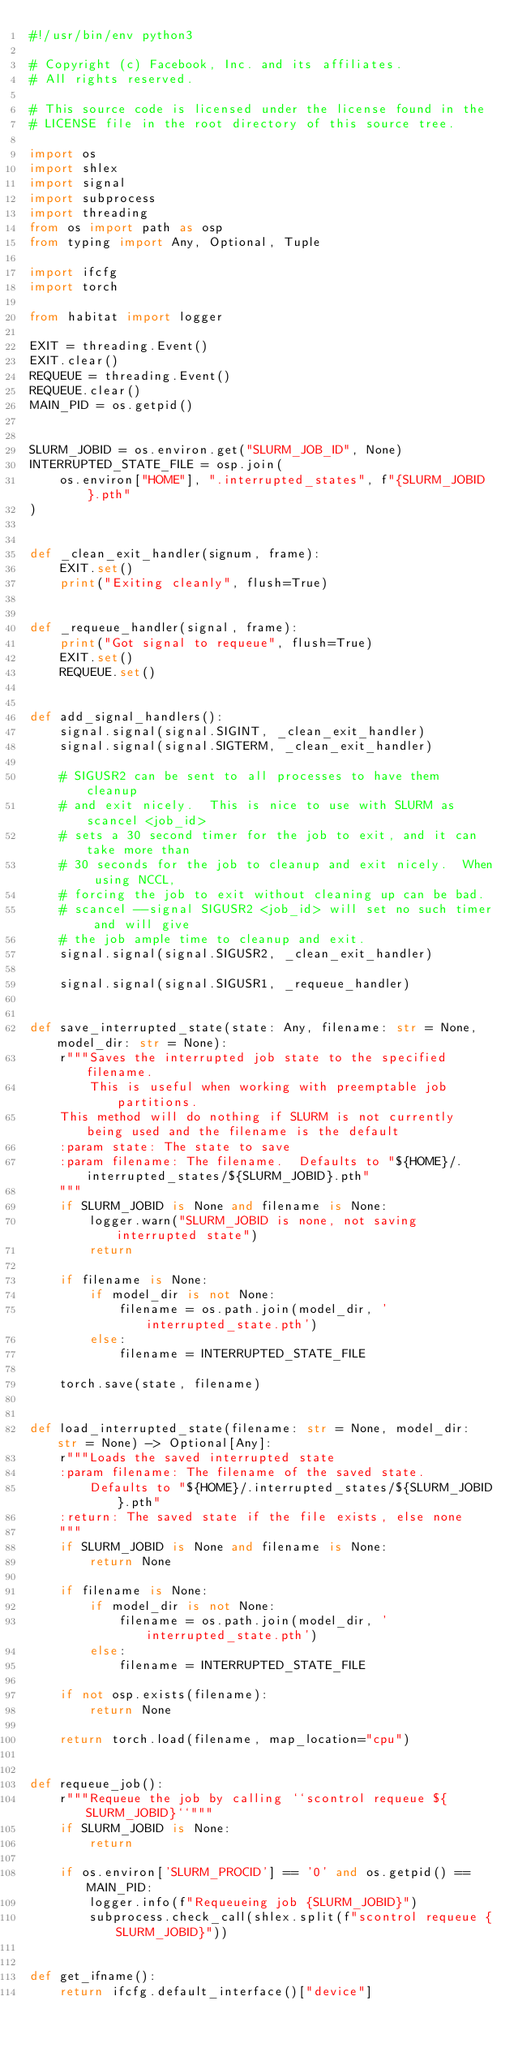Convert code to text. <code><loc_0><loc_0><loc_500><loc_500><_Python_>#!/usr/bin/env python3

# Copyright (c) Facebook, Inc. and its affiliates.
# All rights reserved.

# This source code is licensed under the license found in the
# LICENSE file in the root directory of this source tree.

import os
import shlex
import signal
import subprocess
import threading
from os import path as osp
from typing import Any, Optional, Tuple

import ifcfg
import torch

from habitat import logger

EXIT = threading.Event()
EXIT.clear()
REQUEUE = threading.Event()
REQUEUE.clear()
MAIN_PID = os.getpid()


SLURM_JOBID = os.environ.get("SLURM_JOB_ID", None)
INTERRUPTED_STATE_FILE = osp.join(
    os.environ["HOME"], ".interrupted_states", f"{SLURM_JOBID}.pth"
)


def _clean_exit_handler(signum, frame):
    EXIT.set()
    print("Exiting cleanly", flush=True)


def _requeue_handler(signal, frame):
    print("Got signal to requeue", flush=True)
    EXIT.set()
    REQUEUE.set()


def add_signal_handlers():
    signal.signal(signal.SIGINT, _clean_exit_handler)
    signal.signal(signal.SIGTERM, _clean_exit_handler)

    # SIGUSR2 can be sent to all processes to have them cleanup
    # and exit nicely.  This is nice to use with SLURM as scancel <job_id>
    # sets a 30 second timer for the job to exit, and it can take more than
    # 30 seconds for the job to cleanup and exit nicely.  When using NCCL,
    # forcing the job to exit without cleaning up can be bad.
    # scancel --signal SIGUSR2 <job_id> will set no such timer and will give
    # the job ample time to cleanup and exit.
    signal.signal(signal.SIGUSR2, _clean_exit_handler)

    signal.signal(signal.SIGUSR1, _requeue_handler)


def save_interrupted_state(state: Any, filename: str = None, model_dir: str = None):
    r"""Saves the interrupted job state to the specified filename.
        This is useful when working with preemptable job partitions.
    This method will do nothing if SLURM is not currently being used and the filename is the default
    :param state: The state to save
    :param filename: The filename.  Defaults to "${HOME}/.interrupted_states/${SLURM_JOBID}.pth"
    """
    if SLURM_JOBID is None and filename is None:
        logger.warn("SLURM_JOBID is none, not saving interrupted state")
        return

    if filename is None:
        if model_dir is not None:
            filename = os.path.join(model_dir, 'interrupted_state.pth')
        else:
            filename = INTERRUPTED_STATE_FILE

    torch.save(state, filename)


def load_interrupted_state(filename: str = None, model_dir: str = None) -> Optional[Any]:
    r"""Loads the saved interrupted state
    :param filename: The filename of the saved state.
        Defaults to "${HOME}/.interrupted_states/${SLURM_JOBID}.pth"
    :return: The saved state if the file exists, else none
    """
    if SLURM_JOBID is None and filename is None:
        return None

    if filename is None:
        if model_dir is not None:
            filename = os.path.join(model_dir, 'interrupted_state.pth')
        else:
            filename = INTERRUPTED_STATE_FILE

    if not osp.exists(filename):
        return None

    return torch.load(filename, map_location="cpu")


def requeue_job():
    r"""Requeue the job by calling ``scontrol requeue ${SLURM_JOBID}``"""
    if SLURM_JOBID is None:
        return

    if os.environ['SLURM_PROCID'] == '0' and os.getpid() == MAIN_PID:
        logger.info(f"Requeueing job {SLURM_JOBID}")
        subprocess.check_call(shlex.split(f"scontrol requeue {SLURM_JOBID}"))


def get_ifname():
    return ifcfg.default_interface()["device"]</code> 